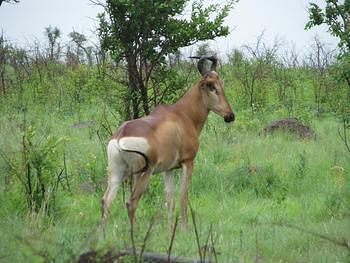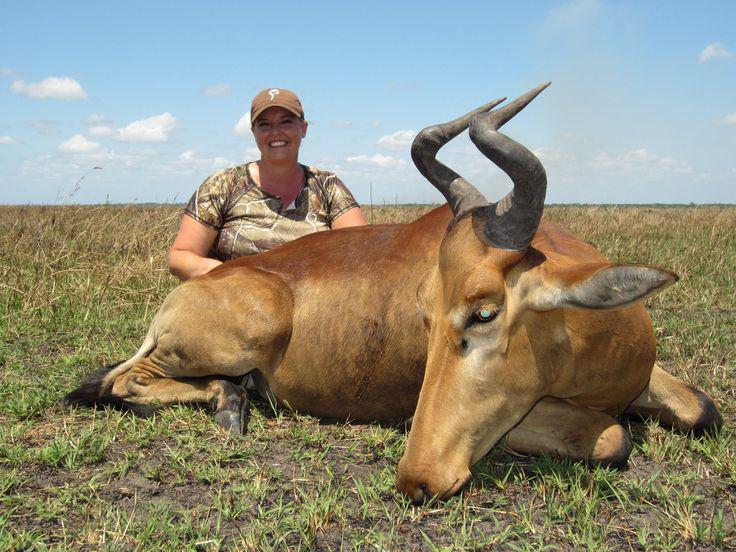The first image is the image on the left, the second image is the image on the right. For the images displayed, is the sentence "In one image, a mammal figure is behind a horned animal." factually correct? Answer yes or no. Yes. 